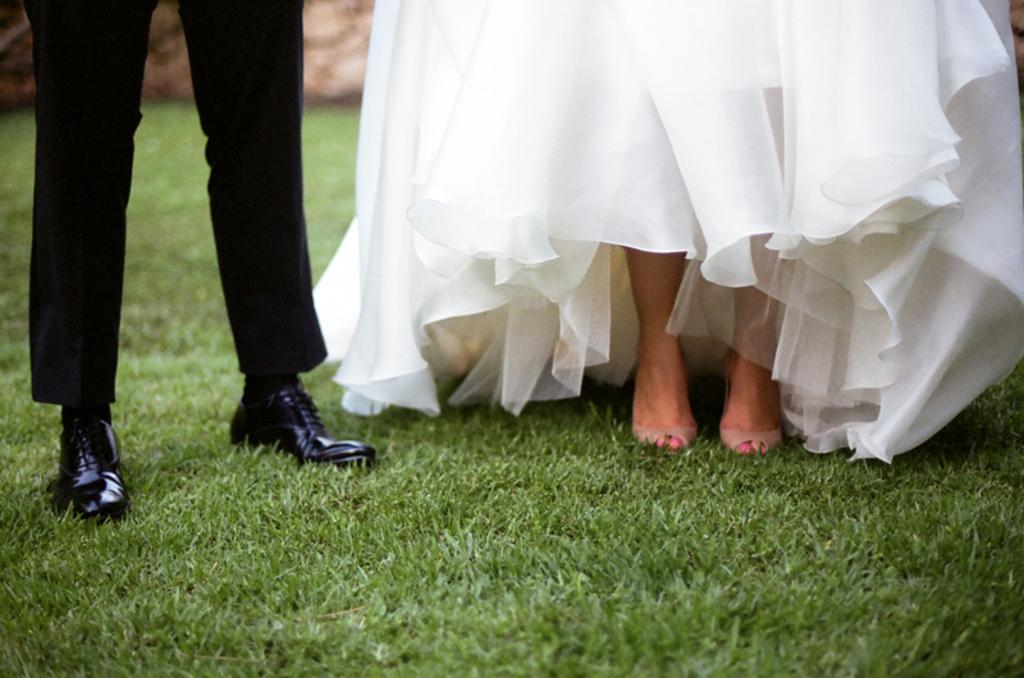What type of vegetation can be seen in the image? There is grass in the image. What body parts of a man are visible in the image? The legs of a man are visible on the grass. What body parts of a woman are visible in the image? The legs of a woman are visible on the grass. What is the man wearing in the image? The man is wearing black trousers. What is the woman wearing in the image? The woman is wearing a white dress. What type of wheel can be seen in the image? There is no wheel present in the image. Is there a beggar asking for money in the image? There is no beggar present in the image. 